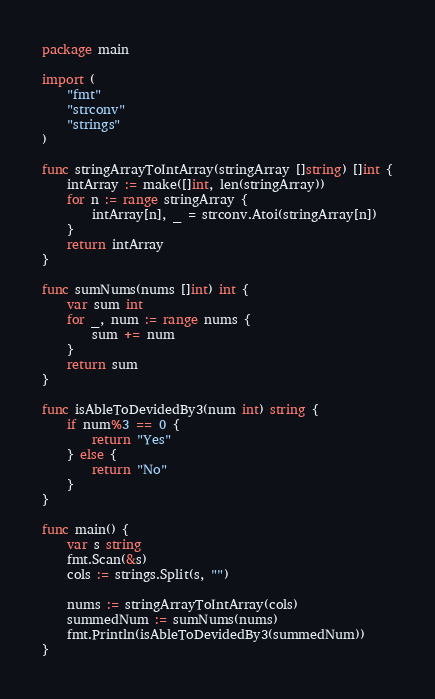<code> <loc_0><loc_0><loc_500><loc_500><_Go_>package main

import (
	"fmt"
	"strconv"
	"strings"
)

func stringArrayToIntArray(stringArray []string) []int {
	intArray := make([]int, len(stringArray))
	for n := range stringArray {
		intArray[n], _ = strconv.Atoi(stringArray[n])
	}
	return intArray
}

func sumNums(nums []int) int {
	var sum int
	for _, num := range nums {
		sum += num
	}
	return sum
}

func isAbleToDevidedBy3(num int) string {
	if num%3 == 0 {
		return "Yes"
	} else {
		return "No"
	}
}

func main() {
	var s string
	fmt.Scan(&s)
	cols := strings.Split(s, "")

	nums := stringArrayToIntArray(cols)
	summedNum := sumNums(nums)
	fmt.Println(isAbleToDevidedBy3(summedNum))
}
</code> 